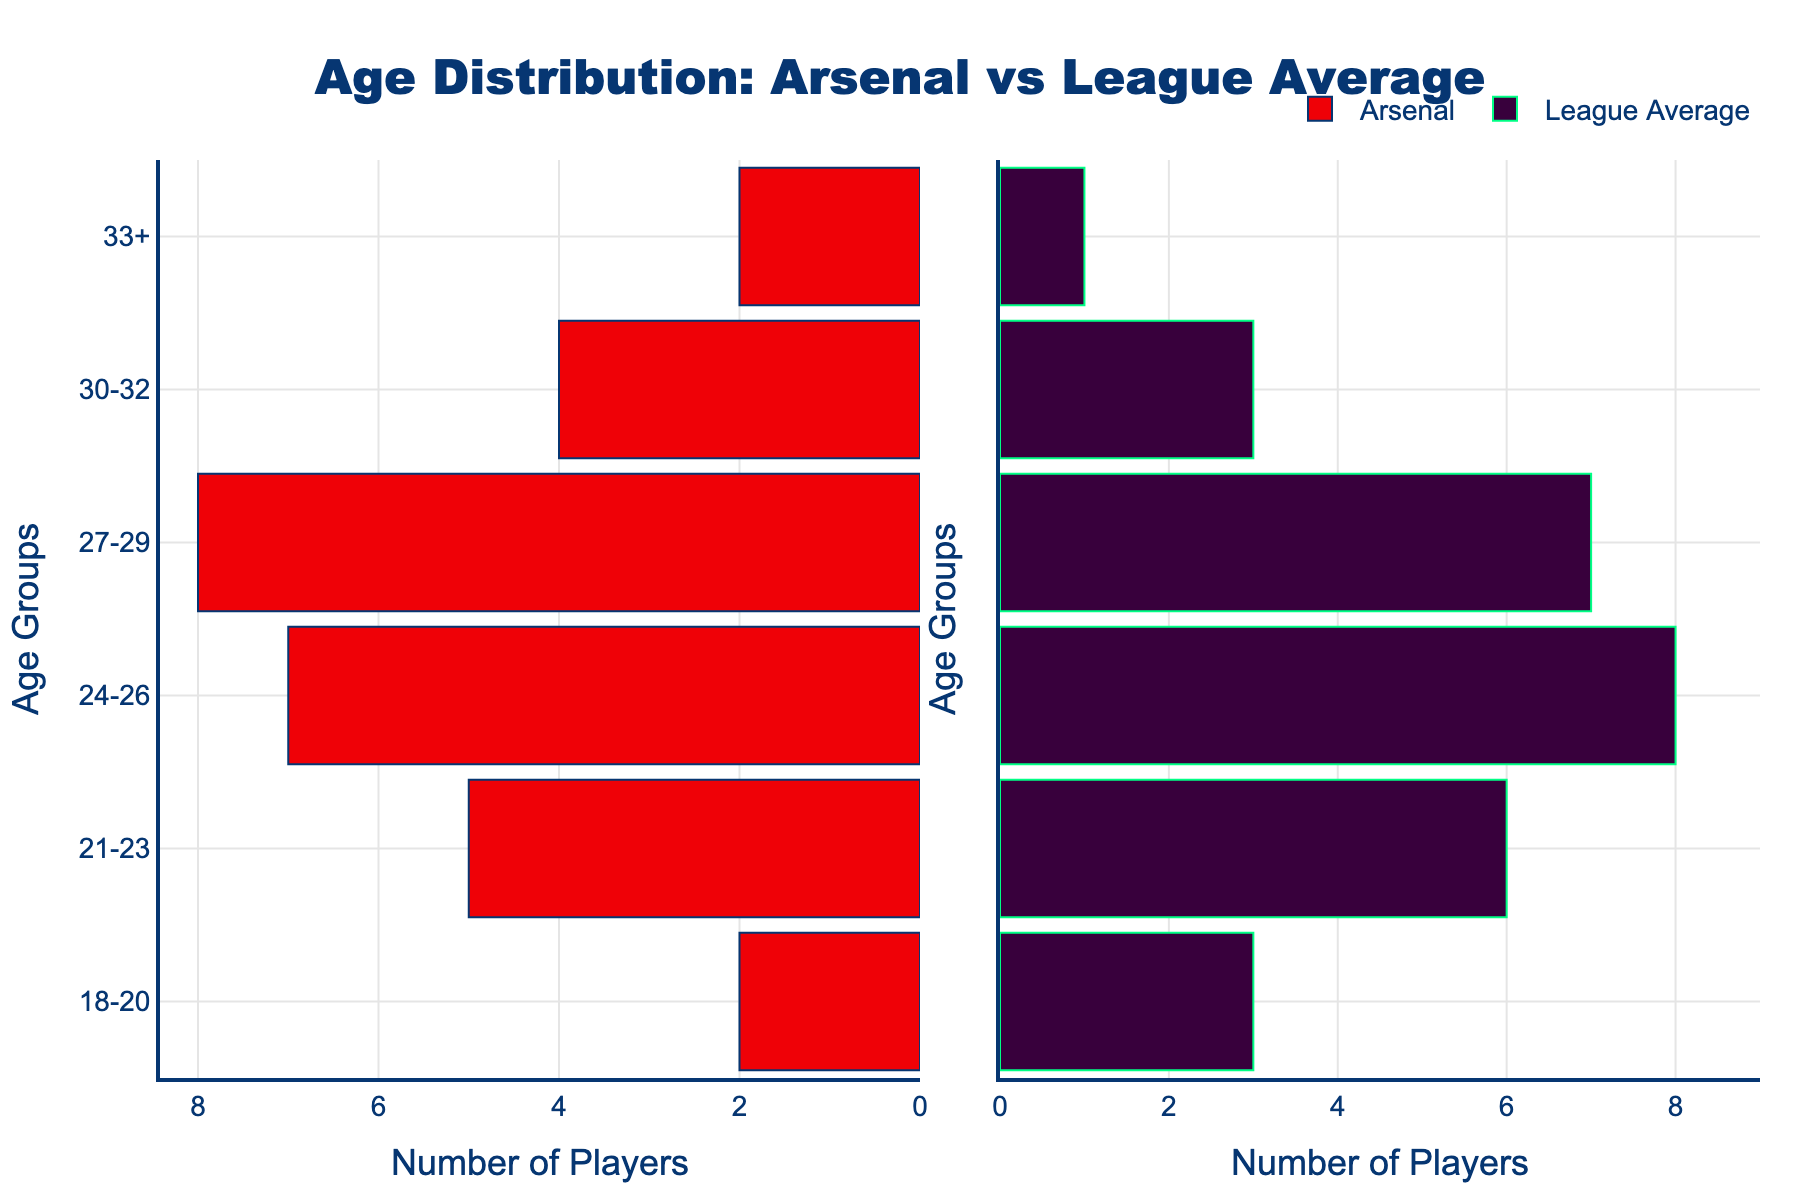What's the title of the figure? The title of the figure is displayed at the top of the plot and reads "Age Distribution: Arsenal vs League Average".
Answer: "Age Distribution: Arsenal vs League Average" In which age group does Arsenal have the maximum number of players? By looking at the height of the bars on the left side of the plot representing Arsenal, the age group 27-29 has the longest bar, indicating it has the maximum number of players.
Answer: 27-29 How many players in Arsenal are aged 33 or older? The bar for Arsenal in the age group 33+ is labeled with the number 2, indicating there are 2 players in this age group.
Answer: 2 Which age group shows a deficit of players in Arsenal compared to the league average? Comparing the lengths of the bars for Arsenal and the league average across age groups, the only age group where Arsenal has a shorter bar is 24-26, indicating a deficit here.
Answer: 24-26 How does the number of Arsenal players aged 27-29 compare to the league average for the same group? By comparing the bars for the age group 27-29, Arsenal has 8 players (as indicated by the height of the bar), while the league average is 7. Therefore, Arsenal has one more player in this age group compared to the league average.
Answer: Arsenal has one more player What is the total number of Arsenal players aged between 18-23? Adding the number of players in the age groups 18-20 and 21-23 for Arsenal (2 + 5), the total is 7.
Answer: 7 In the 30-32 age group, how many more players does Arsenal have compared to the league average? The bar for Arsenal in the age group 30-32 shows 4 players, while the league average bar shows 3 players in this age group, making a difference of 1.
Answer: 1 more player What is the total number of players represented by the league average across all age groups? Adding the values for the league average across all age groups (3 + 6 + 8 + 7 + 3 + 1), the total number is 28.
Answer: 28 Why might Arsenal have a higher number of players in the 33+ age group compared to the league average? Arsenal has 2 players aged 33+, while the league average has 1 player in this age group. This might indicate Arsenal retaining more experienced players for leadership and mentorship roles, which could be a decision made by the management to strike a balance between experience and youth.
Answer: Retaining experienced players What can you infer about Arsenal's strategy from the age distribution of their players? Arsenal seems to have a well-distributed age profile with higher concentrations in the 27-29 and 24-26 age groups. This could reflect a strategy to maintain a core team in their prime playing years while supplementing with younger talent and experienced players.
Answer: Balance of ages 